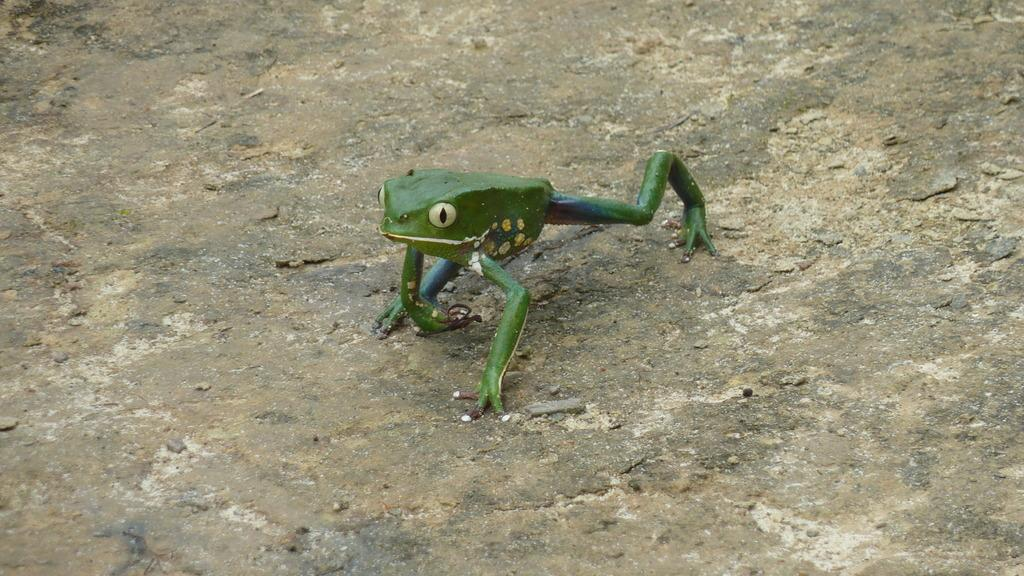What animal is present in the image? There is a frog in the image. Where is the frog located? The frog is on the ground. Which direction is the frog facing in the image? The provided facts do not mention the direction the frog is facing, so we cannot answer this question definitively. 